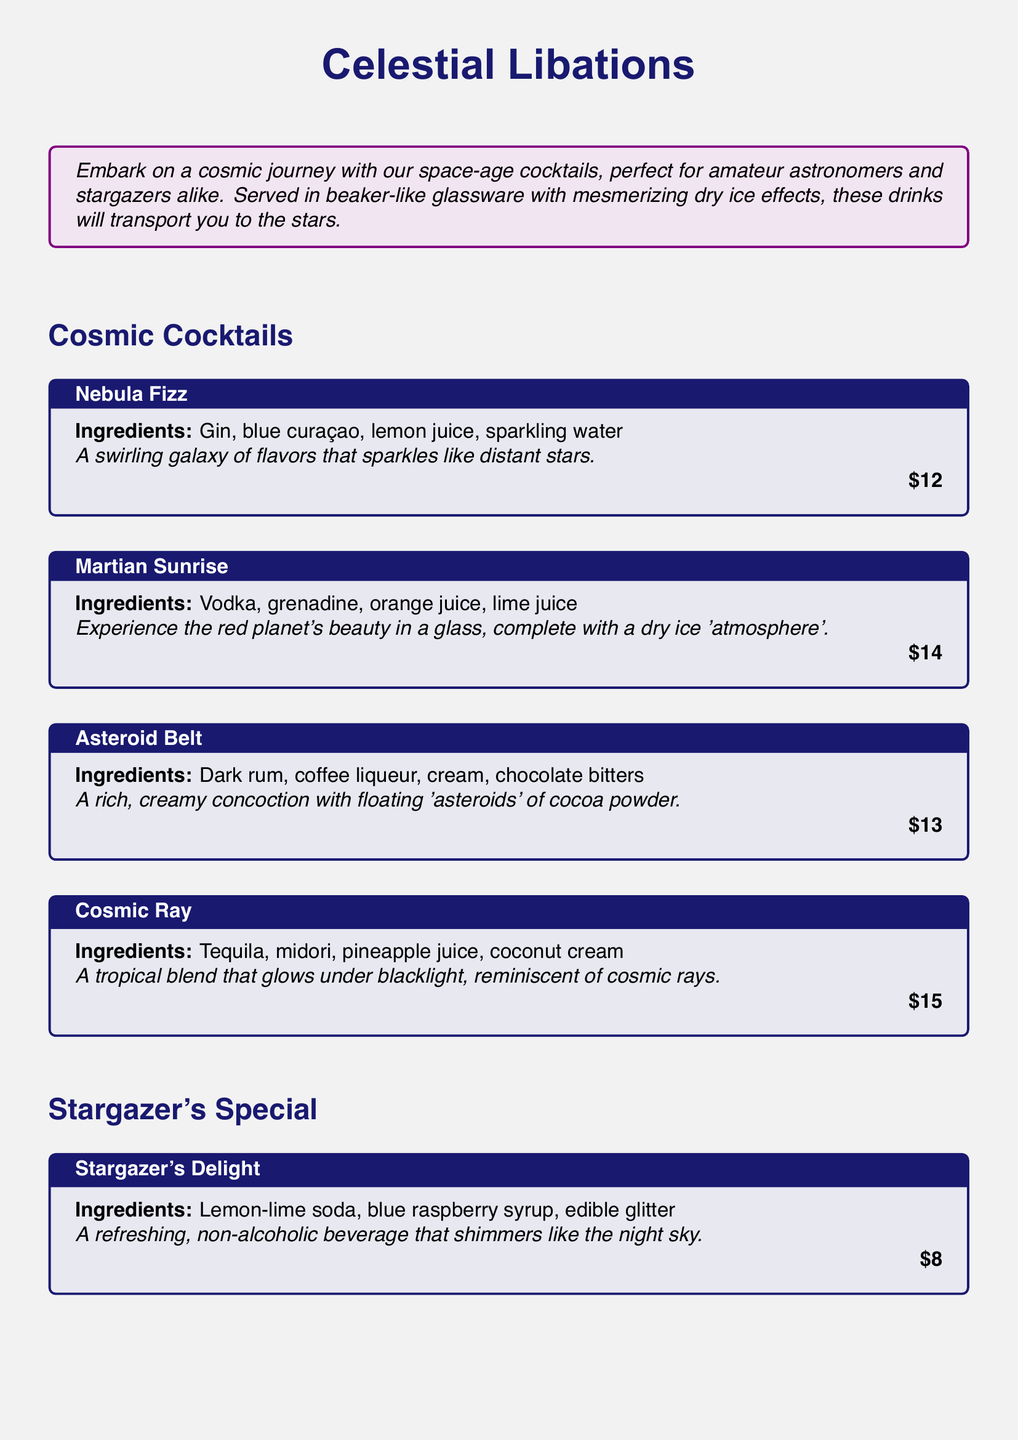What is the title of the cocktail menu? The title of the cocktail menu is prominently displayed at the top of the document, which is "Celestial Libations."
Answer: Celestial Libations What ingredients are in the Nebula Fizz? The ingredients for the Nebula Fizz are listed in the cocktail section of the document.
Answer: Gin, blue curaçao, lemon juice, sparkling water How much does the Martian Sunrise cost? The cost of the Martian Sunrise is specified directly under the cocktail description.
Answer: $14 What type of glass is used to serve the cocktails? Information about the glassware is provided in the note towards the end of the document.
Answer: 500ml borosilicate glass beakers Which cocktail is non-alcoholic? The non-alcoholic cocktail is mentioned in the Stargazer's Special section of the menu.
Answer: Stargazer's Delight What color is associated with the Cosmic Ray cocktail under blacklight? The description of the Cosmic Ray cocktail includes a detail about its visual effect.
Answer: Glows How many cocktails are listed in the Cosmic Cocktails section? The number of cocktails can be counted in the provided section of the menu.
Answer: Four What is the effect of dry ice in the cocktails? The document describes the effect of dry ice in the note at the bottom.
Answer: Misty, otherworldly effect What is used to enhance the Stargazer's Delight visually? The visual enhancement for the Stargazer's Delight is specified in its description.
Answer: Edible glitter 